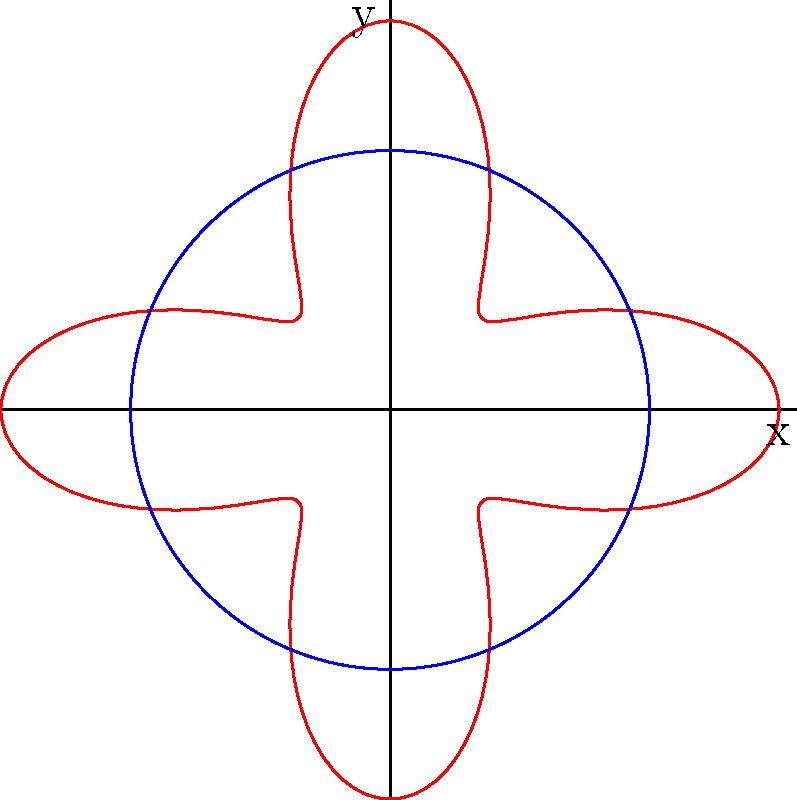In exploring circular Indigenous art patterns, you come across a polar equation $r = 2 + \cos(4\theta)$. How many petals or lobes does this pattern create, and what is the significance of the constant term in relation to the base circle? To answer this question, let's break it down step-by-step:

1) The polar equation is given as $r = 2 + \cos(4\theta)$

2) In polar equations of the form $r = a + b\cos(n\theta)$ or $r = a + b\sin(n\theta)$:
   - $n$ determines the number of petals or lobes
   - $a$ is the radius of the base circle
   - $b$ affects the size of the petals

3) In our equation, $n = 4$, which means the pattern will have 4 petals or lobes.

4) The constant term $a = 2$ represents the radius of the base circle.

5) The coefficient of $\cos(4\theta)$ is 1, which determines the size of the petals relative to the base circle.

6) The pattern oscillates between $r = 1$ (when $\cos(4\theta) = -1$) and $r = 3$ (when $\cos(4\theta) = 1$).

7) The constant term (2) ensures that the pattern never reaches the origin, as the minimum value of $r$ is 1.

Therefore, the pattern creates 4 petals or lobes, and the constant term (2) represents the radius of the base circle around which the pattern is formed.
Answer: 4 petals; base circle radius 